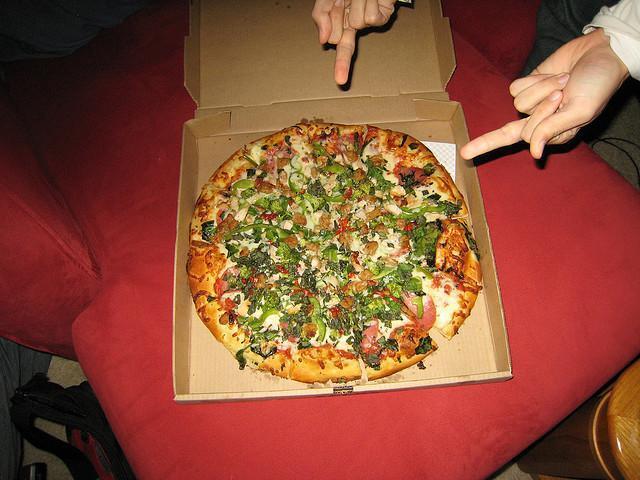Verify the accuracy of this image caption: "The person is touching the pizza.".
Answer yes or no. No. 